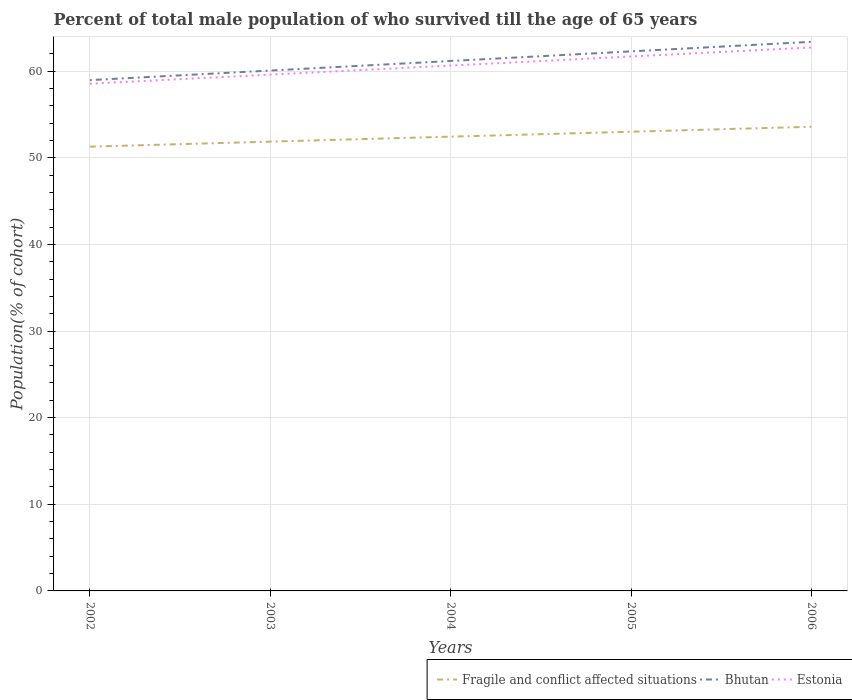How many different coloured lines are there?
Ensure brevity in your answer.  3. Across all years, what is the maximum percentage of total male population who survived till the age of 65 years in Estonia?
Give a very brief answer. 58.55. In which year was the percentage of total male population who survived till the age of 65 years in Estonia maximum?
Provide a short and direct response. 2002. What is the total percentage of total male population who survived till the age of 65 years in Bhutan in the graph?
Ensure brevity in your answer.  -1.11. What is the difference between the highest and the second highest percentage of total male population who survived till the age of 65 years in Fragile and conflict affected situations?
Provide a short and direct response. 2.3. Is the percentage of total male population who survived till the age of 65 years in Estonia strictly greater than the percentage of total male population who survived till the age of 65 years in Fragile and conflict affected situations over the years?
Offer a terse response. No. Are the values on the major ticks of Y-axis written in scientific E-notation?
Keep it short and to the point. No. How many legend labels are there?
Give a very brief answer. 3. What is the title of the graph?
Provide a short and direct response. Percent of total male population of who survived till the age of 65 years. Does "Zambia" appear as one of the legend labels in the graph?
Make the answer very short. No. What is the label or title of the X-axis?
Provide a short and direct response. Years. What is the label or title of the Y-axis?
Provide a short and direct response. Population(% of cohort). What is the Population(% of cohort) of Fragile and conflict affected situations in 2002?
Give a very brief answer. 51.28. What is the Population(% of cohort) in Bhutan in 2002?
Offer a very short reply. 58.96. What is the Population(% of cohort) of Estonia in 2002?
Make the answer very short. 58.55. What is the Population(% of cohort) in Fragile and conflict affected situations in 2003?
Ensure brevity in your answer.  51.86. What is the Population(% of cohort) of Bhutan in 2003?
Provide a short and direct response. 60.06. What is the Population(% of cohort) in Estonia in 2003?
Offer a very short reply. 59.59. What is the Population(% of cohort) of Fragile and conflict affected situations in 2004?
Your answer should be compact. 52.44. What is the Population(% of cohort) of Bhutan in 2004?
Provide a short and direct response. 61.17. What is the Population(% of cohort) in Estonia in 2004?
Your answer should be very brief. 60.64. What is the Population(% of cohort) of Fragile and conflict affected situations in 2005?
Keep it short and to the point. 53. What is the Population(% of cohort) of Bhutan in 2005?
Provide a short and direct response. 62.28. What is the Population(% of cohort) of Estonia in 2005?
Provide a short and direct response. 61.69. What is the Population(% of cohort) in Fragile and conflict affected situations in 2006?
Keep it short and to the point. 53.58. What is the Population(% of cohort) of Bhutan in 2006?
Your response must be concise. 63.38. What is the Population(% of cohort) of Estonia in 2006?
Keep it short and to the point. 62.73. Across all years, what is the maximum Population(% of cohort) of Fragile and conflict affected situations?
Keep it short and to the point. 53.58. Across all years, what is the maximum Population(% of cohort) in Bhutan?
Your response must be concise. 63.38. Across all years, what is the maximum Population(% of cohort) of Estonia?
Give a very brief answer. 62.73. Across all years, what is the minimum Population(% of cohort) of Fragile and conflict affected situations?
Your answer should be compact. 51.28. Across all years, what is the minimum Population(% of cohort) of Bhutan?
Make the answer very short. 58.96. Across all years, what is the minimum Population(% of cohort) of Estonia?
Your answer should be very brief. 58.55. What is the total Population(% of cohort) in Fragile and conflict affected situations in the graph?
Offer a very short reply. 262.16. What is the total Population(% of cohort) in Bhutan in the graph?
Offer a terse response. 305.85. What is the total Population(% of cohort) in Estonia in the graph?
Keep it short and to the point. 303.2. What is the difference between the Population(% of cohort) of Fragile and conflict affected situations in 2002 and that in 2003?
Keep it short and to the point. -0.58. What is the difference between the Population(% of cohort) in Bhutan in 2002 and that in 2003?
Offer a very short reply. -1.11. What is the difference between the Population(% of cohort) in Estonia in 2002 and that in 2003?
Provide a succinct answer. -1.05. What is the difference between the Population(% of cohort) in Fragile and conflict affected situations in 2002 and that in 2004?
Ensure brevity in your answer.  -1.15. What is the difference between the Population(% of cohort) in Bhutan in 2002 and that in 2004?
Provide a short and direct response. -2.21. What is the difference between the Population(% of cohort) of Estonia in 2002 and that in 2004?
Ensure brevity in your answer.  -2.09. What is the difference between the Population(% of cohort) in Fragile and conflict affected situations in 2002 and that in 2005?
Offer a very short reply. -1.72. What is the difference between the Population(% of cohort) in Bhutan in 2002 and that in 2005?
Provide a short and direct response. -3.32. What is the difference between the Population(% of cohort) in Estonia in 2002 and that in 2005?
Make the answer very short. -3.14. What is the difference between the Population(% of cohort) of Fragile and conflict affected situations in 2002 and that in 2006?
Your response must be concise. -2.3. What is the difference between the Population(% of cohort) in Bhutan in 2002 and that in 2006?
Make the answer very short. -4.42. What is the difference between the Population(% of cohort) in Estonia in 2002 and that in 2006?
Your answer should be very brief. -4.18. What is the difference between the Population(% of cohort) in Fragile and conflict affected situations in 2003 and that in 2004?
Offer a terse response. -0.57. What is the difference between the Population(% of cohort) in Bhutan in 2003 and that in 2004?
Make the answer very short. -1.11. What is the difference between the Population(% of cohort) of Estonia in 2003 and that in 2004?
Provide a short and direct response. -1.05. What is the difference between the Population(% of cohort) of Fragile and conflict affected situations in 2003 and that in 2005?
Ensure brevity in your answer.  -1.14. What is the difference between the Population(% of cohort) in Bhutan in 2003 and that in 2005?
Offer a terse response. -2.21. What is the difference between the Population(% of cohort) in Estonia in 2003 and that in 2005?
Your answer should be compact. -2.09. What is the difference between the Population(% of cohort) in Fragile and conflict affected situations in 2003 and that in 2006?
Ensure brevity in your answer.  -1.72. What is the difference between the Population(% of cohort) of Bhutan in 2003 and that in 2006?
Provide a short and direct response. -3.32. What is the difference between the Population(% of cohort) of Estonia in 2003 and that in 2006?
Give a very brief answer. -3.14. What is the difference between the Population(% of cohort) of Fragile and conflict affected situations in 2004 and that in 2005?
Offer a very short reply. -0.57. What is the difference between the Population(% of cohort) of Bhutan in 2004 and that in 2005?
Provide a succinct answer. -1.11. What is the difference between the Population(% of cohort) in Estonia in 2004 and that in 2005?
Provide a short and direct response. -1.05. What is the difference between the Population(% of cohort) of Fragile and conflict affected situations in 2004 and that in 2006?
Make the answer very short. -1.14. What is the difference between the Population(% of cohort) in Bhutan in 2004 and that in 2006?
Offer a terse response. -2.21. What is the difference between the Population(% of cohort) in Estonia in 2004 and that in 2006?
Your response must be concise. -2.09. What is the difference between the Population(% of cohort) of Fragile and conflict affected situations in 2005 and that in 2006?
Make the answer very short. -0.58. What is the difference between the Population(% of cohort) of Bhutan in 2005 and that in 2006?
Provide a succinct answer. -1.11. What is the difference between the Population(% of cohort) in Estonia in 2005 and that in 2006?
Give a very brief answer. -1.05. What is the difference between the Population(% of cohort) in Fragile and conflict affected situations in 2002 and the Population(% of cohort) in Bhutan in 2003?
Offer a terse response. -8.78. What is the difference between the Population(% of cohort) of Fragile and conflict affected situations in 2002 and the Population(% of cohort) of Estonia in 2003?
Give a very brief answer. -8.31. What is the difference between the Population(% of cohort) in Bhutan in 2002 and the Population(% of cohort) in Estonia in 2003?
Make the answer very short. -0.64. What is the difference between the Population(% of cohort) of Fragile and conflict affected situations in 2002 and the Population(% of cohort) of Bhutan in 2004?
Give a very brief answer. -9.89. What is the difference between the Population(% of cohort) in Fragile and conflict affected situations in 2002 and the Population(% of cohort) in Estonia in 2004?
Make the answer very short. -9.36. What is the difference between the Population(% of cohort) in Bhutan in 2002 and the Population(% of cohort) in Estonia in 2004?
Your answer should be very brief. -1.68. What is the difference between the Population(% of cohort) of Fragile and conflict affected situations in 2002 and the Population(% of cohort) of Bhutan in 2005?
Give a very brief answer. -11. What is the difference between the Population(% of cohort) of Fragile and conflict affected situations in 2002 and the Population(% of cohort) of Estonia in 2005?
Provide a succinct answer. -10.41. What is the difference between the Population(% of cohort) of Bhutan in 2002 and the Population(% of cohort) of Estonia in 2005?
Keep it short and to the point. -2.73. What is the difference between the Population(% of cohort) in Fragile and conflict affected situations in 2002 and the Population(% of cohort) in Bhutan in 2006?
Your response must be concise. -12.1. What is the difference between the Population(% of cohort) of Fragile and conflict affected situations in 2002 and the Population(% of cohort) of Estonia in 2006?
Give a very brief answer. -11.45. What is the difference between the Population(% of cohort) of Bhutan in 2002 and the Population(% of cohort) of Estonia in 2006?
Make the answer very short. -3.77. What is the difference between the Population(% of cohort) of Fragile and conflict affected situations in 2003 and the Population(% of cohort) of Bhutan in 2004?
Offer a very short reply. -9.31. What is the difference between the Population(% of cohort) of Fragile and conflict affected situations in 2003 and the Population(% of cohort) of Estonia in 2004?
Provide a succinct answer. -8.78. What is the difference between the Population(% of cohort) of Bhutan in 2003 and the Population(% of cohort) of Estonia in 2004?
Your answer should be very brief. -0.58. What is the difference between the Population(% of cohort) in Fragile and conflict affected situations in 2003 and the Population(% of cohort) in Bhutan in 2005?
Your answer should be very brief. -10.42. What is the difference between the Population(% of cohort) in Fragile and conflict affected situations in 2003 and the Population(% of cohort) in Estonia in 2005?
Make the answer very short. -9.83. What is the difference between the Population(% of cohort) in Bhutan in 2003 and the Population(% of cohort) in Estonia in 2005?
Provide a short and direct response. -1.62. What is the difference between the Population(% of cohort) of Fragile and conflict affected situations in 2003 and the Population(% of cohort) of Bhutan in 2006?
Offer a very short reply. -11.52. What is the difference between the Population(% of cohort) in Fragile and conflict affected situations in 2003 and the Population(% of cohort) in Estonia in 2006?
Keep it short and to the point. -10.87. What is the difference between the Population(% of cohort) of Bhutan in 2003 and the Population(% of cohort) of Estonia in 2006?
Keep it short and to the point. -2.67. What is the difference between the Population(% of cohort) in Fragile and conflict affected situations in 2004 and the Population(% of cohort) in Bhutan in 2005?
Offer a very short reply. -9.84. What is the difference between the Population(% of cohort) of Fragile and conflict affected situations in 2004 and the Population(% of cohort) of Estonia in 2005?
Provide a succinct answer. -9.25. What is the difference between the Population(% of cohort) of Bhutan in 2004 and the Population(% of cohort) of Estonia in 2005?
Offer a very short reply. -0.52. What is the difference between the Population(% of cohort) of Fragile and conflict affected situations in 2004 and the Population(% of cohort) of Bhutan in 2006?
Your answer should be very brief. -10.95. What is the difference between the Population(% of cohort) of Fragile and conflict affected situations in 2004 and the Population(% of cohort) of Estonia in 2006?
Ensure brevity in your answer.  -10.3. What is the difference between the Population(% of cohort) of Bhutan in 2004 and the Population(% of cohort) of Estonia in 2006?
Give a very brief answer. -1.56. What is the difference between the Population(% of cohort) of Fragile and conflict affected situations in 2005 and the Population(% of cohort) of Bhutan in 2006?
Offer a very short reply. -10.38. What is the difference between the Population(% of cohort) of Fragile and conflict affected situations in 2005 and the Population(% of cohort) of Estonia in 2006?
Give a very brief answer. -9.73. What is the difference between the Population(% of cohort) of Bhutan in 2005 and the Population(% of cohort) of Estonia in 2006?
Ensure brevity in your answer.  -0.46. What is the average Population(% of cohort) of Fragile and conflict affected situations per year?
Your answer should be compact. 52.43. What is the average Population(% of cohort) of Bhutan per year?
Keep it short and to the point. 61.17. What is the average Population(% of cohort) of Estonia per year?
Your response must be concise. 60.64. In the year 2002, what is the difference between the Population(% of cohort) in Fragile and conflict affected situations and Population(% of cohort) in Bhutan?
Your answer should be very brief. -7.68. In the year 2002, what is the difference between the Population(% of cohort) in Fragile and conflict affected situations and Population(% of cohort) in Estonia?
Your answer should be compact. -7.27. In the year 2002, what is the difference between the Population(% of cohort) in Bhutan and Population(% of cohort) in Estonia?
Make the answer very short. 0.41. In the year 2003, what is the difference between the Population(% of cohort) of Fragile and conflict affected situations and Population(% of cohort) of Bhutan?
Provide a succinct answer. -8.2. In the year 2003, what is the difference between the Population(% of cohort) in Fragile and conflict affected situations and Population(% of cohort) in Estonia?
Make the answer very short. -7.73. In the year 2003, what is the difference between the Population(% of cohort) of Bhutan and Population(% of cohort) of Estonia?
Keep it short and to the point. 0.47. In the year 2004, what is the difference between the Population(% of cohort) in Fragile and conflict affected situations and Population(% of cohort) in Bhutan?
Your response must be concise. -8.73. In the year 2004, what is the difference between the Population(% of cohort) in Fragile and conflict affected situations and Population(% of cohort) in Estonia?
Offer a very short reply. -8.21. In the year 2004, what is the difference between the Population(% of cohort) of Bhutan and Population(% of cohort) of Estonia?
Your answer should be compact. 0.53. In the year 2005, what is the difference between the Population(% of cohort) of Fragile and conflict affected situations and Population(% of cohort) of Bhutan?
Your answer should be compact. -9.27. In the year 2005, what is the difference between the Population(% of cohort) of Fragile and conflict affected situations and Population(% of cohort) of Estonia?
Offer a very short reply. -8.68. In the year 2005, what is the difference between the Population(% of cohort) in Bhutan and Population(% of cohort) in Estonia?
Offer a terse response. 0.59. In the year 2006, what is the difference between the Population(% of cohort) of Fragile and conflict affected situations and Population(% of cohort) of Bhutan?
Make the answer very short. -9.8. In the year 2006, what is the difference between the Population(% of cohort) in Fragile and conflict affected situations and Population(% of cohort) in Estonia?
Your answer should be compact. -9.15. In the year 2006, what is the difference between the Population(% of cohort) in Bhutan and Population(% of cohort) in Estonia?
Give a very brief answer. 0.65. What is the ratio of the Population(% of cohort) in Fragile and conflict affected situations in 2002 to that in 2003?
Offer a very short reply. 0.99. What is the ratio of the Population(% of cohort) of Bhutan in 2002 to that in 2003?
Offer a very short reply. 0.98. What is the ratio of the Population(% of cohort) in Estonia in 2002 to that in 2003?
Offer a terse response. 0.98. What is the ratio of the Population(% of cohort) in Bhutan in 2002 to that in 2004?
Provide a short and direct response. 0.96. What is the ratio of the Population(% of cohort) in Estonia in 2002 to that in 2004?
Your response must be concise. 0.97. What is the ratio of the Population(% of cohort) in Fragile and conflict affected situations in 2002 to that in 2005?
Make the answer very short. 0.97. What is the ratio of the Population(% of cohort) in Bhutan in 2002 to that in 2005?
Your answer should be compact. 0.95. What is the ratio of the Population(% of cohort) of Estonia in 2002 to that in 2005?
Provide a short and direct response. 0.95. What is the ratio of the Population(% of cohort) in Fragile and conflict affected situations in 2002 to that in 2006?
Your response must be concise. 0.96. What is the ratio of the Population(% of cohort) in Bhutan in 2002 to that in 2006?
Ensure brevity in your answer.  0.93. What is the ratio of the Population(% of cohort) of Fragile and conflict affected situations in 2003 to that in 2004?
Offer a terse response. 0.99. What is the ratio of the Population(% of cohort) of Bhutan in 2003 to that in 2004?
Provide a short and direct response. 0.98. What is the ratio of the Population(% of cohort) of Estonia in 2003 to that in 2004?
Give a very brief answer. 0.98. What is the ratio of the Population(% of cohort) of Fragile and conflict affected situations in 2003 to that in 2005?
Your answer should be compact. 0.98. What is the ratio of the Population(% of cohort) in Bhutan in 2003 to that in 2005?
Your response must be concise. 0.96. What is the ratio of the Population(% of cohort) of Estonia in 2003 to that in 2005?
Provide a short and direct response. 0.97. What is the ratio of the Population(% of cohort) in Fragile and conflict affected situations in 2003 to that in 2006?
Keep it short and to the point. 0.97. What is the ratio of the Population(% of cohort) of Bhutan in 2003 to that in 2006?
Your answer should be compact. 0.95. What is the ratio of the Population(% of cohort) in Fragile and conflict affected situations in 2004 to that in 2005?
Your answer should be compact. 0.99. What is the ratio of the Population(% of cohort) of Bhutan in 2004 to that in 2005?
Provide a succinct answer. 0.98. What is the ratio of the Population(% of cohort) of Estonia in 2004 to that in 2005?
Your response must be concise. 0.98. What is the ratio of the Population(% of cohort) in Fragile and conflict affected situations in 2004 to that in 2006?
Your response must be concise. 0.98. What is the ratio of the Population(% of cohort) of Bhutan in 2004 to that in 2006?
Your answer should be compact. 0.97. What is the ratio of the Population(% of cohort) in Estonia in 2004 to that in 2006?
Your answer should be compact. 0.97. What is the ratio of the Population(% of cohort) in Bhutan in 2005 to that in 2006?
Ensure brevity in your answer.  0.98. What is the ratio of the Population(% of cohort) of Estonia in 2005 to that in 2006?
Your response must be concise. 0.98. What is the difference between the highest and the second highest Population(% of cohort) in Fragile and conflict affected situations?
Offer a terse response. 0.58. What is the difference between the highest and the second highest Population(% of cohort) of Bhutan?
Keep it short and to the point. 1.11. What is the difference between the highest and the second highest Population(% of cohort) in Estonia?
Provide a short and direct response. 1.05. What is the difference between the highest and the lowest Population(% of cohort) in Fragile and conflict affected situations?
Your response must be concise. 2.3. What is the difference between the highest and the lowest Population(% of cohort) of Bhutan?
Make the answer very short. 4.42. What is the difference between the highest and the lowest Population(% of cohort) of Estonia?
Your answer should be compact. 4.18. 